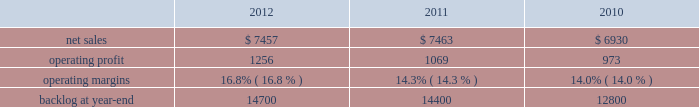2011 compared to 2010 is&gs 2019 net sales for 2011 decreased $ 540 million , or 5% ( 5 % ) , compared to 2010 .
The decrease primarily was attributable to lower volume of approximately $ 665 million due to the absence of the dris program that supported the 2010 u.s .
Census and a decline in activities on the jtrs program .
This decrease partially was offset by increased net sales on numerous programs .
Is&gs 2019 operating profit for 2011 increased $ 60 million , or 7% ( 7 % ) , compared to 2010 .
Operating profit increased approximately $ 180 million due to volume and the retirement of risks in 2011 and the absence of reserves recognized in 2010 on numerous programs ( including among others , odin ( about $ 60 million ) and twic and automated flight service station programs ) .
The increases in operating profit partially were offset by the absence of the dris program and a decline in activities on the jtrs program of about $ 120 million .
Adjustments not related to volume , including net profit rate adjustments described above , were approximately $ 130 million higher in 2011 compared to 2010 .
Backlog backlog decreased in 2012 compared to 2011 primarily due to the substantial completion of various programs in 2011 ( primarily odin , u.k .
Census , and jtrs ) .
The decrease in backlog during 2011 compared to 2010 mainly was due to declining activities on the jtrs program and several other smaller programs .
Trends we expect is&gs 2019 net sales to decline in 2013 in the mid single digit percentage range as compared to 2012 primarily due to the continued downturn in federal information technology budgets .
Operating profit is expected to decline in 2013 in the mid single digit percentage range consistent with the expected decline in net sales , resulting in margins that are comparable with 2012 results .
Missiles and fire control our mfc business segment provides air and missile defense systems ; tactical missiles and air-to-ground precision strike weapon systems ; fire control systems ; mission operations support , readiness , engineering support , and integration services ; logistics and other technical services ; and manned and unmanned ground vehicles .
Mfc 2019s major programs include pac-3 , thaad , multiple launch rocket system ( mlrs ) , hellfire , javelin , joint air-to-surface standoff missile ( jassm ) , apache fire control system ( apache ) , sniper ae , low altitude navigation and targeting infrared for night ( lantirn ae ) , and sof clss .
Mfc 2019s operating results included the following ( in millions ) : .
2012 compared to 2011 mfc 2019s net sales for 2012 were comparable to 2011 .
Net sales decreased approximately $ 130 million due to lower volume and risk retirements on various services programs , and about $ 60 million due to lower volume from fire control systems programs ( primarily sniper ae ; lantirn ae ; and apache ) .
The decreases largely were offset by higher net sales of approximately $ 95 million due to higher volume from tactical missile programs ( primarily javelin and hellfire ) and approximately $ 80 million for air and missile defense programs ( primarily pac-3 and thaad ) .
Mfc 2019s operating profit for 2012 increased $ 187 million , or 17% ( 17 % ) , compared to 2011 .
The increase was attributable to higher risk retirements and volume of about $ 95 million from tactical missile programs ( primarily javelin and hellfire ) ; increased risk retirements and volume of approximately $ 60 million for air and missile defense programs ( primarily thaad and pac-3 ) ; and about $ 45 million from a resolution of contractual matters .
Partially offsetting these increases was lower risk retirements and volume on various programs , including $ 25 million for services programs .
Adjustments not related to volume , including net profit booking rate adjustments and other matters described above , were approximately $ 145 million higher for 2012 compared to 2011. .
What was the percentage increase in the operating profit from 2010 to 2011? 
Computations: ((1069 - 973) / 973)
Answer: 0.09866. 